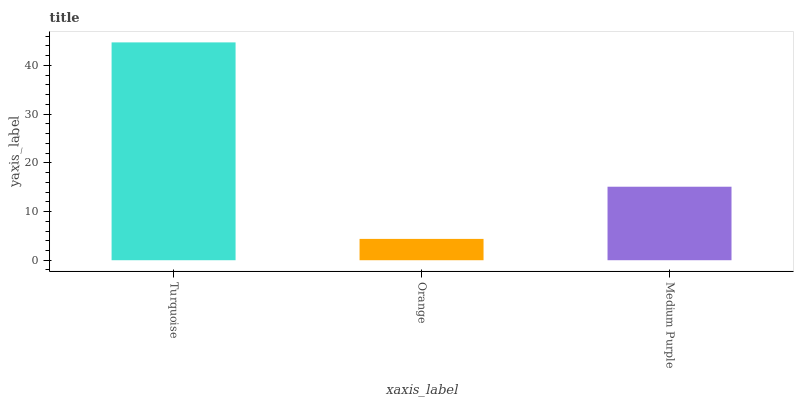Is Orange the minimum?
Answer yes or no. Yes. Is Turquoise the maximum?
Answer yes or no. Yes. Is Medium Purple the minimum?
Answer yes or no. No. Is Medium Purple the maximum?
Answer yes or no. No. Is Medium Purple greater than Orange?
Answer yes or no. Yes. Is Orange less than Medium Purple?
Answer yes or no. Yes. Is Orange greater than Medium Purple?
Answer yes or no. No. Is Medium Purple less than Orange?
Answer yes or no. No. Is Medium Purple the high median?
Answer yes or no. Yes. Is Medium Purple the low median?
Answer yes or no. Yes. Is Turquoise the high median?
Answer yes or no. No. Is Orange the low median?
Answer yes or no. No. 